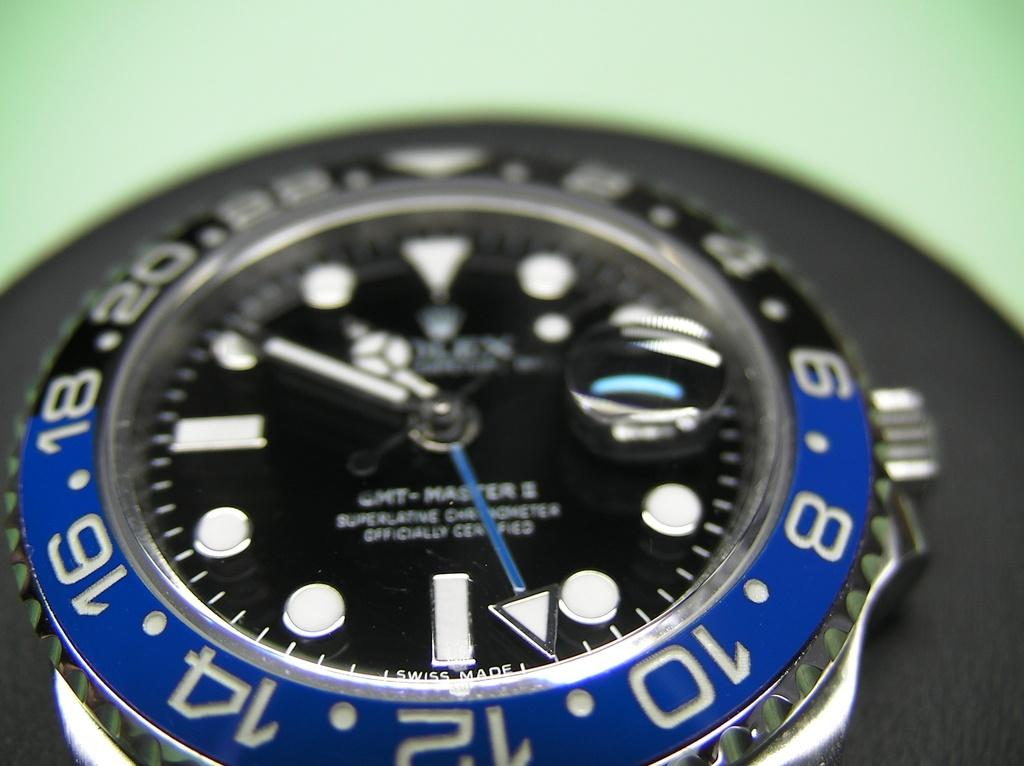<image>
Render a clear and concise summary of the photo. Face of a watch which says OFFICIALLY CERTIFIED on it. 